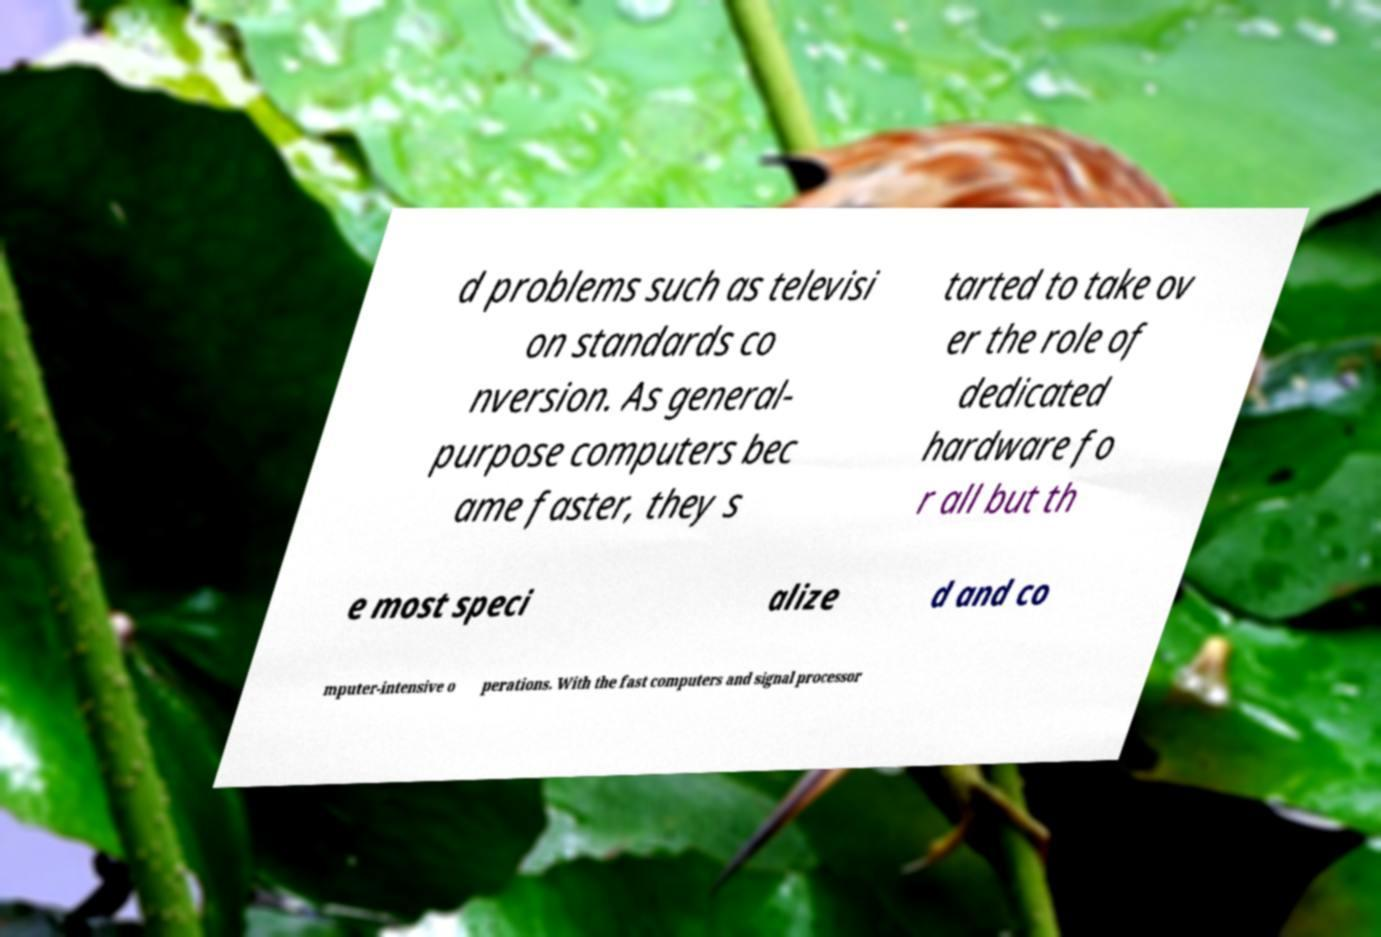What messages or text are displayed in this image? I need them in a readable, typed format. d problems such as televisi on standards co nversion. As general- purpose computers bec ame faster, they s tarted to take ov er the role of dedicated hardware fo r all but th e most speci alize d and co mputer-intensive o perations. With the fast computers and signal processor 